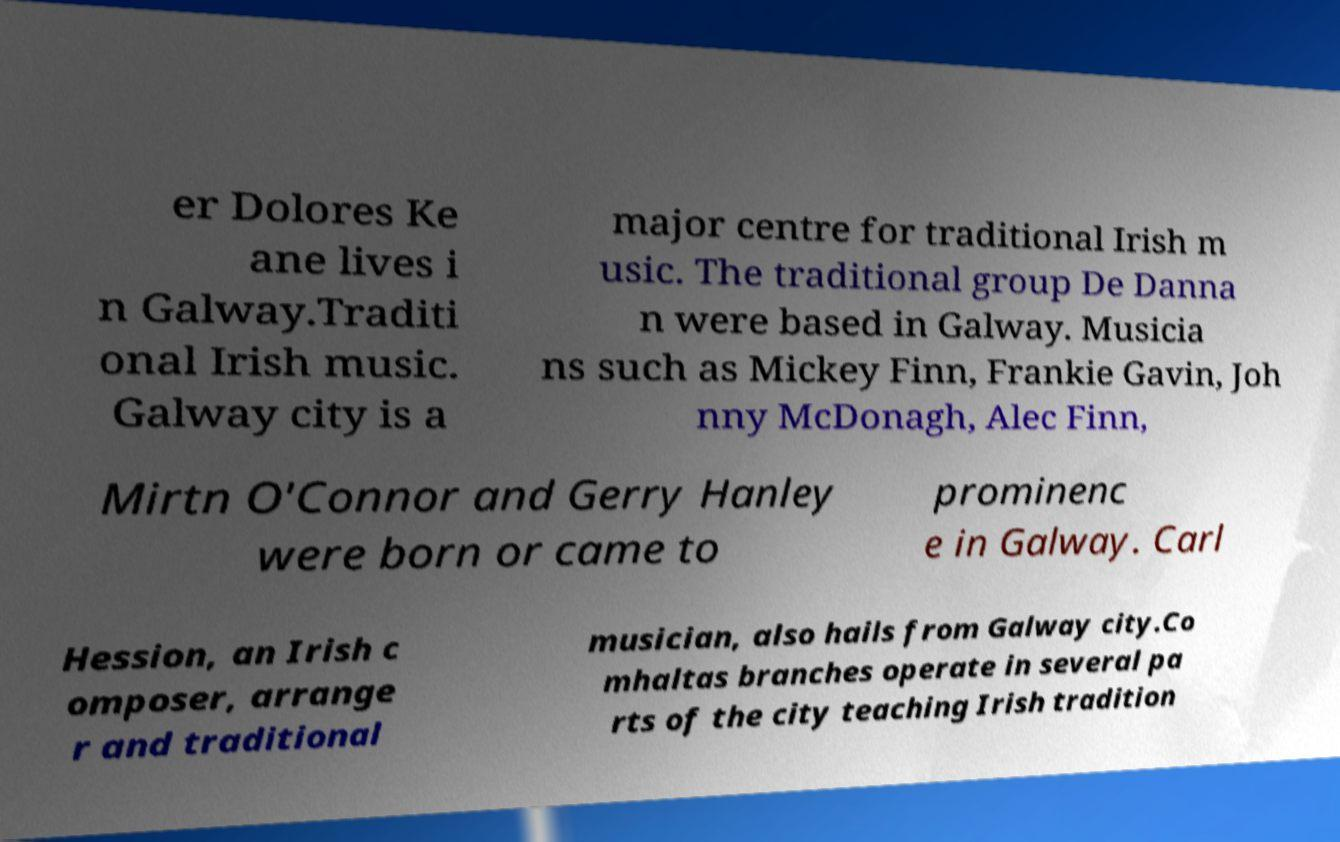For documentation purposes, I need the text within this image transcribed. Could you provide that? er Dolores Ke ane lives i n Galway.Traditi onal Irish music. Galway city is a major centre for traditional Irish m usic. The traditional group De Danna n were based in Galway. Musicia ns such as Mickey Finn, Frankie Gavin, Joh nny McDonagh, Alec Finn, Mirtn O'Connor and Gerry Hanley were born or came to prominenc e in Galway. Carl Hession, an Irish c omposer, arrange r and traditional musician, also hails from Galway city.Co mhaltas branches operate in several pa rts of the city teaching Irish tradition 